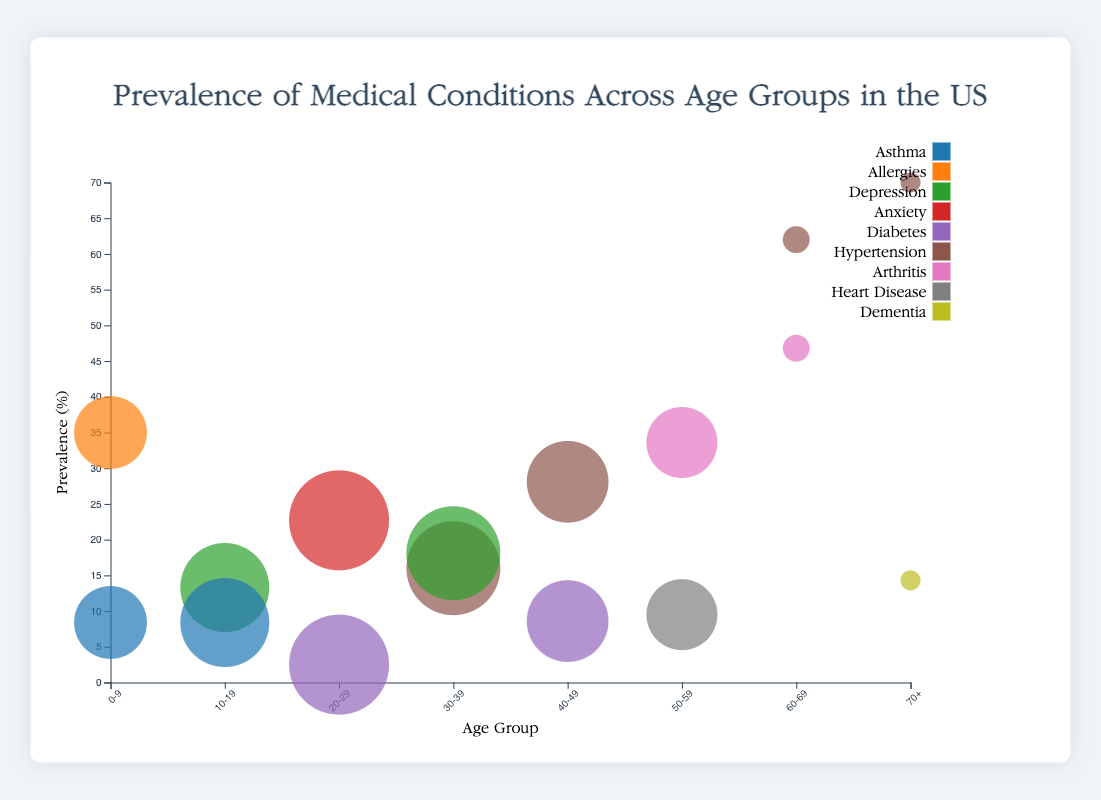What's the title of the figure? The title is located at the top center of the figure and describes the main topic of the chart.
Answer: Prevalence of Medical Conditions Across Age Groups in the US How many different medical conditions are shown in the chart? By examining the legend on the right side of the chart, you can count the distinct colors representing different medical conditions.
Answer: 10 Which age group has the highest prevalence of hypertension? By looking at the y-axis and identifying the largest bubbles for hypertension (color-coded), you can see which age group they belong to.
Answer: 70+ What is the prevalence percentage of asthma in the 0-9 age group? Locate the bubble for the 0-9 age group at the x-axis and match the color representing asthma, then read the prevalence percentage from the y-axis.
Answer: 8.4% Which condition affects the greatest number of people in the 20-29 age group? By comparing the size of bubbles for each condition within the 20-29 age group, the largest bubble represents the condition affecting the most people.
Answer: Anxiety How does the prevalence of hypertension change as age increases from 30-39 to 70+? Identify and compare the bubbles for hypertension across the age groups from 30-39 to 70+, and observe the trend in their y-values (prevalence percentage).
Answer: It increases Which age group has the smallest population affected by heart disease? Compare the size of the bubbles (representing population size) for heart disease across different age groups, smallest one is the answer.
Answer: 50-59 What condition has the second-highest prevalence percentage in the 50-59 age group? Inside 50-59 age group, sort the bubbles based on the y-axis values (prevalence percentage) and find the second highest one.
Answer: Heart Disease How many conditions have a prevalence percentage greater than 20% in the 60-69 age group? Identify and count bubbles in the 60-69 age group with y-values higher than 20%.
Answer: 2 What is the difference in diabetes prevalence between the 20-29 and 40-49 age groups? Identify the bubbles for diabetes in both age groups and calculate the difference in their y-values (prevalence percentage).
Answer: 6.1% 